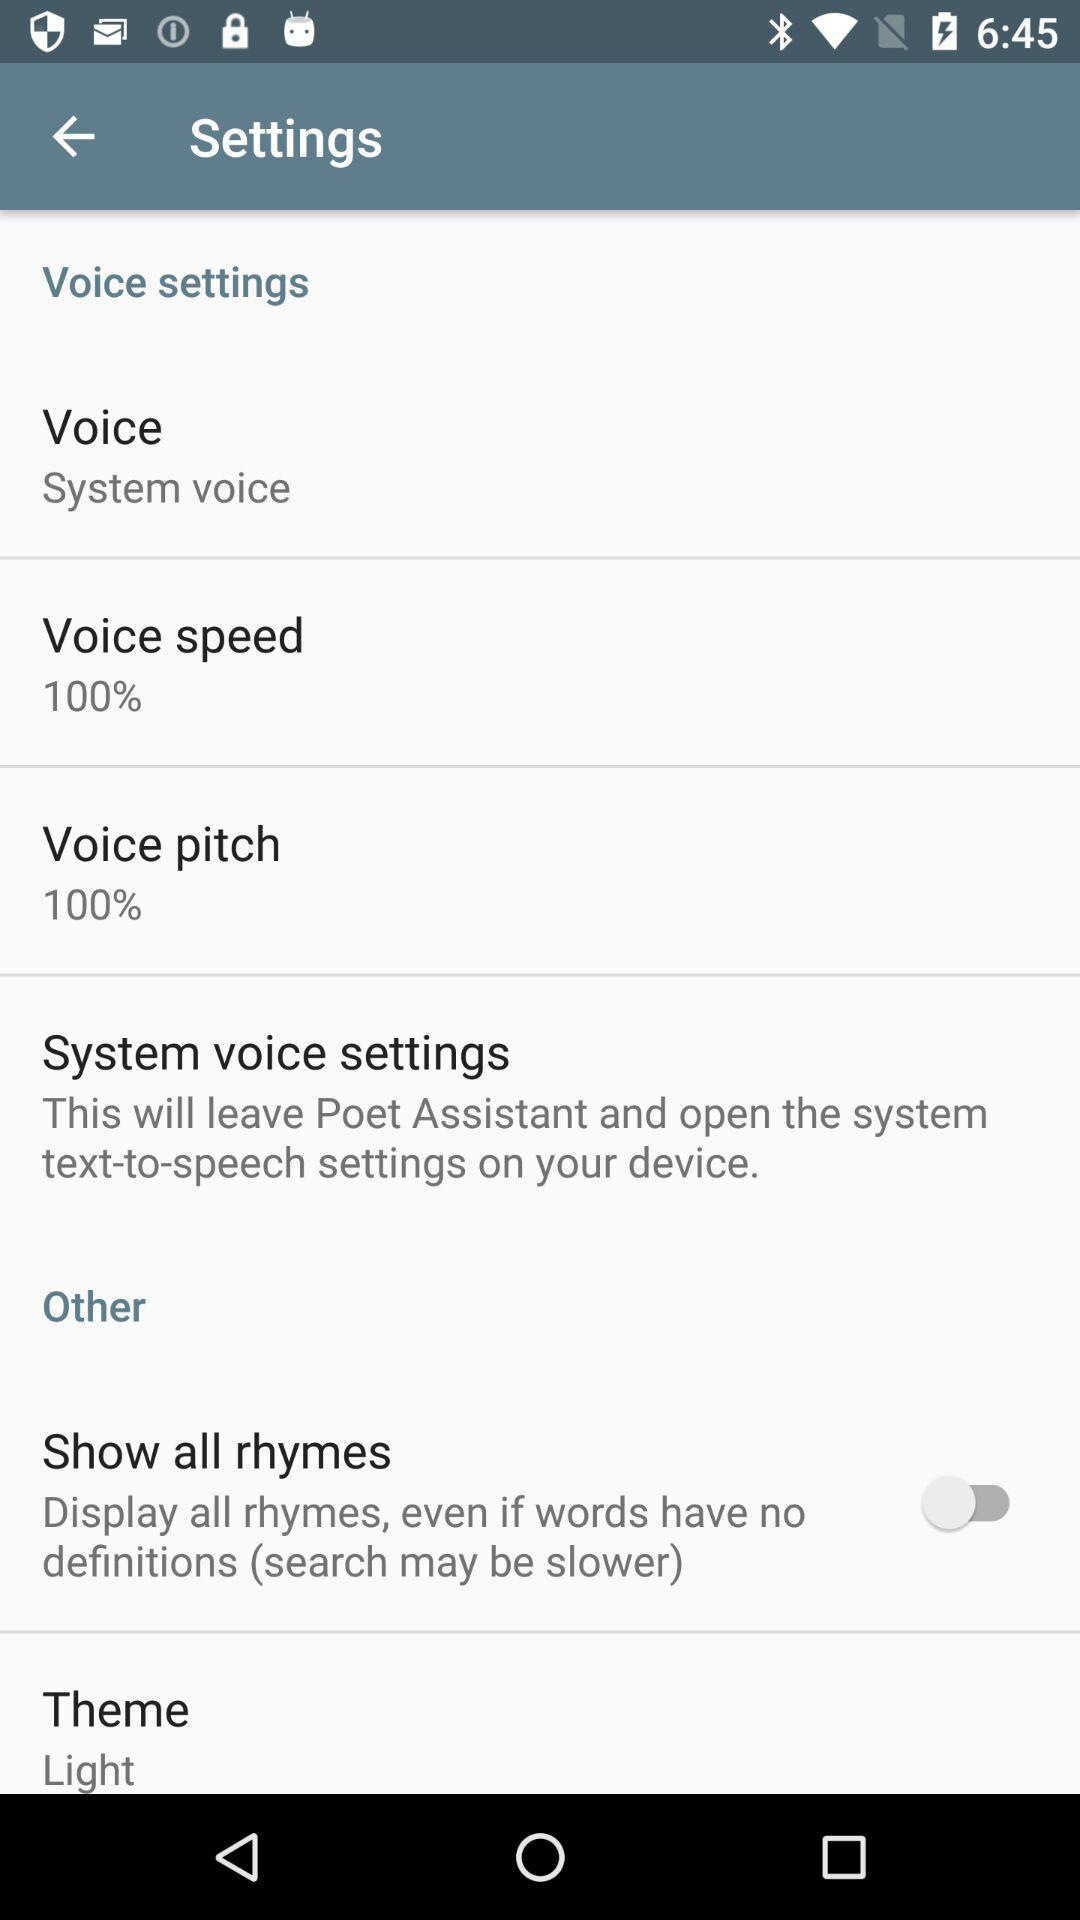What is the setting for "Voice pitch"? The setting for "Voice pitch" is "100%". 